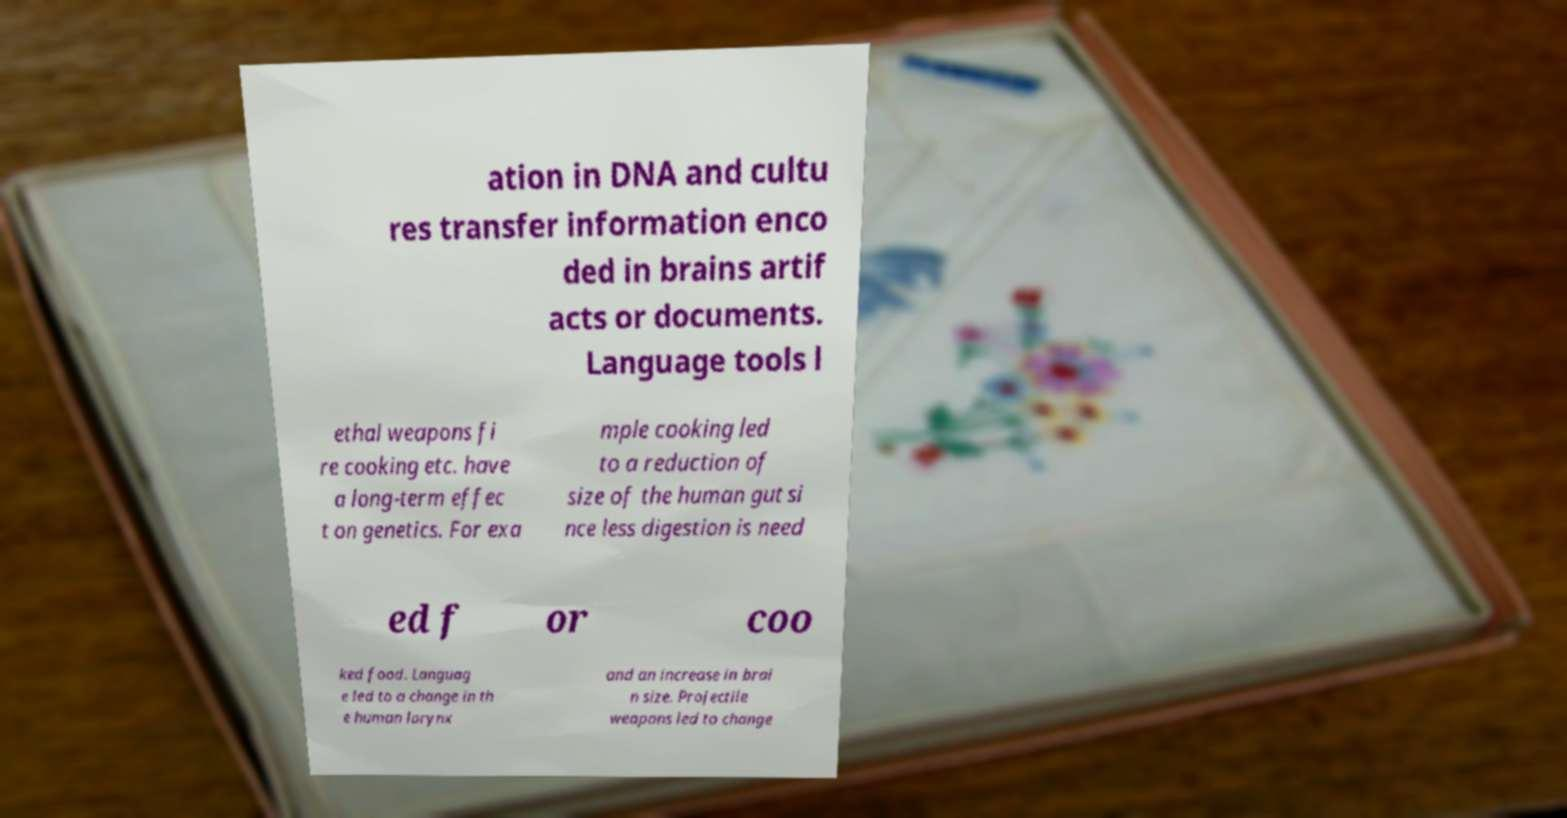There's text embedded in this image that I need extracted. Can you transcribe it verbatim? ation in DNA and cultu res transfer information enco ded in brains artif acts or documents. Language tools l ethal weapons fi re cooking etc. have a long-term effec t on genetics. For exa mple cooking led to a reduction of size of the human gut si nce less digestion is need ed f or coo ked food. Languag e led to a change in th e human larynx and an increase in brai n size. Projectile weapons led to change 